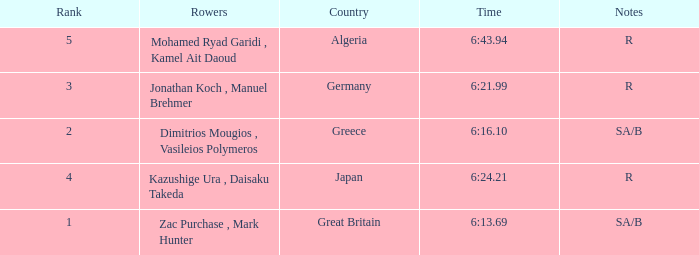What country is ranked #2? Greece. Parse the full table. {'header': ['Rank', 'Rowers', 'Country', 'Time', 'Notes'], 'rows': [['5', 'Mohamed Ryad Garidi , Kamel Ait Daoud', 'Algeria', '6:43.94', 'R'], ['3', 'Jonathan Koch , Manuel Brehmer', 'Germany', '6:21.99', 'R'], ['2', 'Dimitrios Mougios , Vasileios Polymeros', 'Greece', '6:16.10', 'SA/B'], ['4', 'Kazushige Ura , Daisaku Takeda', 'Japan', '6:24.21', 'R'], ['1', 'Zac Purchase , Mark Hunter', 'Great Britain', '6:13.69', 'SA/B']]} 